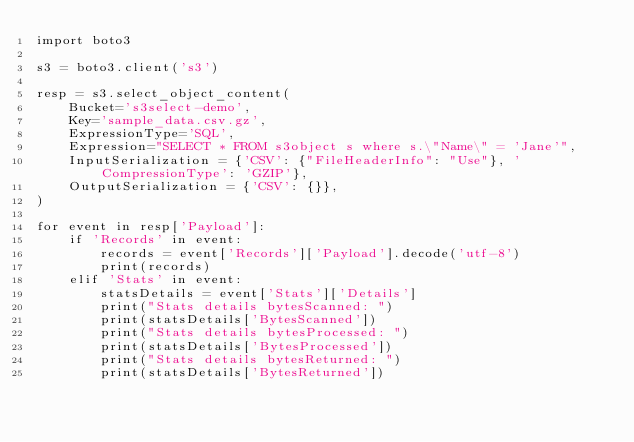<code> <loc_0><loc_0><loc_500><loc_500><_Python_>import boto3

s3 = boto3.client('s3')

resp = s3.select_object_content(
    Bucket='s3select-demo',
    Key='sample_data.csv.gz',
    ExpressionType='SQL',
    Expression="SELECT * FROM s3object s where s.\"Name\" = 'Jane'",
    InputSerialization = {'CSV': {"FileHeaderInfo": "Use"}, 'CompressionType': 'GZIP'},
    OutputSerialization = {'CSV': {}},
)

for event in resp['Payload']:
    if 'Records' in event:
        records = event['Records']['Payload'].decode('utf-8')
        print(records)
    elif 'Stats' in event:
        statsDetails = event['Stats']['Details']
        print("Stats details bytesScanned: ")
        print(statsDetails['BytesScanned'])
        print("Stats details bytesProcessed: ")
        print(statsDetails['BytesProcessed'])
        print("Stats details bytesReturned: ")
        print(statsDetails['BytesReturned'])</code> 